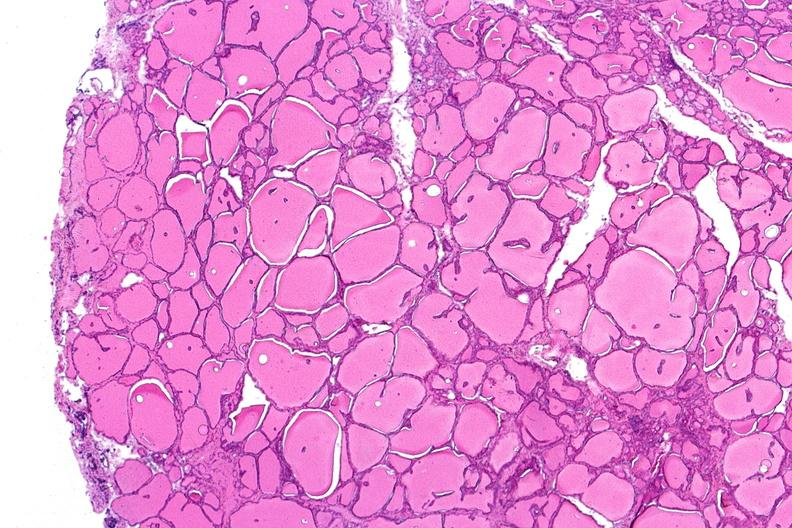s endocrine present?
Answer the question using a single word or phrase. Yes 